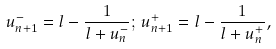Convert formula to latex. <formula><loc_0><loc_0><loc_500><loc_500>u _ { n + 1 } ^ { - } = l - \frac { 1 } { l + u _ { n } ^ { - } } ; \, u _ { n + 1 } ^ { + } = l - \frac { 1 } { l + u _ { n } ^ { + } } ,</formula> 